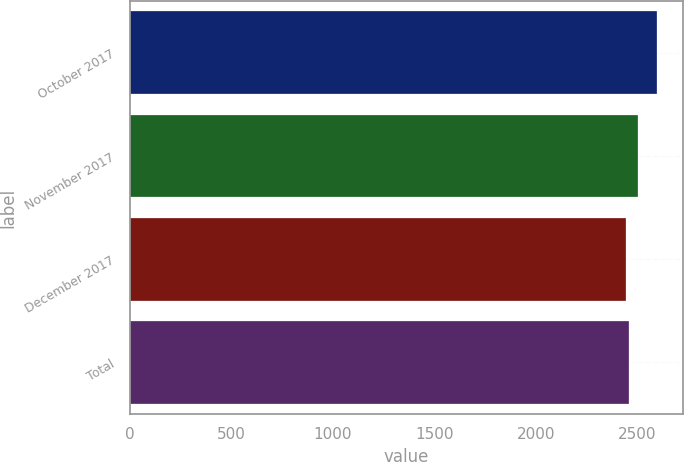<chart> <loc_0><loc_0><loc_500><loc_500><bar_chart><fcel>October 2017<fcel>November 2017<fcel>December 2017<fcel>Total<nl><fcel>2596<fcel>2504<fcel>2446<fcel>2461<nl></chart> 